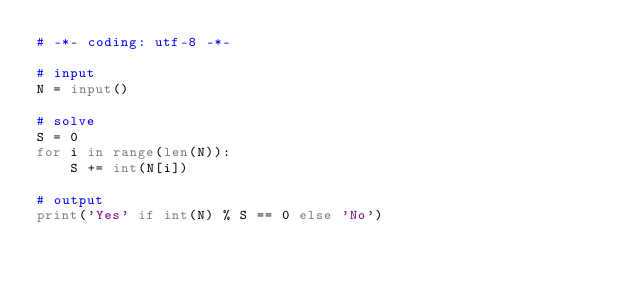<code> <loc_0><loc_0><loc_500><loc_500><_Python_># -*- coding: utf-8 -*-

# input
N = input()

# solve
S = 0
for i in range(len(N)):
    S += int(N[i])

# output
print('Yes' if int(N) % S == 0 else 'No')
</code> 